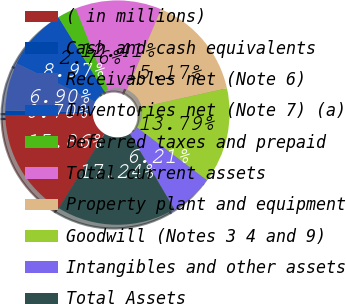<chart> <loc_0><loc_0><loc_500><loc_500><pie_chart><fcel>( in millions)<fcel>Cash and cash equivalents<fcel>Receivables net (Note 6)<fcel>Inventories net (Note 7) (a)<fcel>Deferred taxes and prepaid<fcel>Total current assets<fcel>Property plant and equipment<fcel>Goodwill (Notes 3 4 and 9)<fcel>Intangibles and other assets<fcel>Total Assets<nl><fcel>15.86%<fcel>0.7%<fcel>6.9%<fcel>8.97%<fcel>2.76%<fcel>12.41%<fcel>15.17%<fcel>13.79%<fcel>6.21%<fcel>17.24%<nl></chart> 